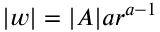<formula> <loc_0><loc_0><loc_500><loc_500>| w | = | A | a r ^ { a - 1 }</formula> 